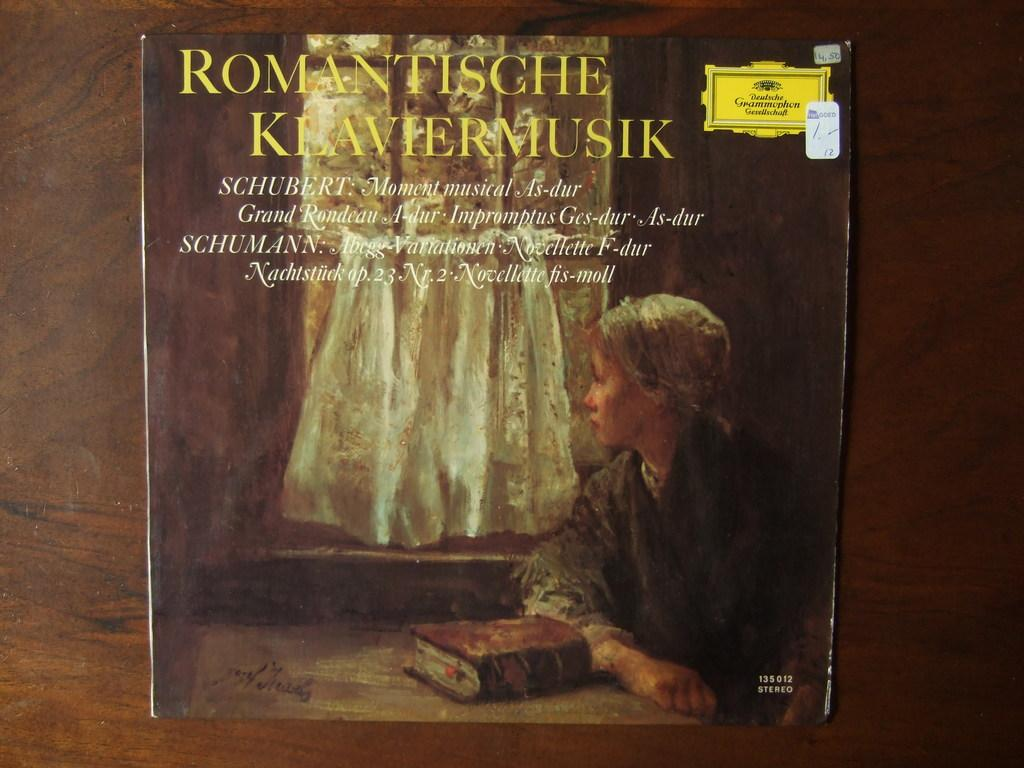<image>
Provide a brief description of the given image. An album cover for music by Schubert and Shumann. 